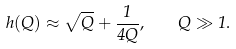<formula> <loc_0><loc_0><loc_500><loc_500>h ( Q ) \approx \sqrt { Q } + \frac { 1 } { 4 Q } , \quad Q \gg 1 .</formula> 